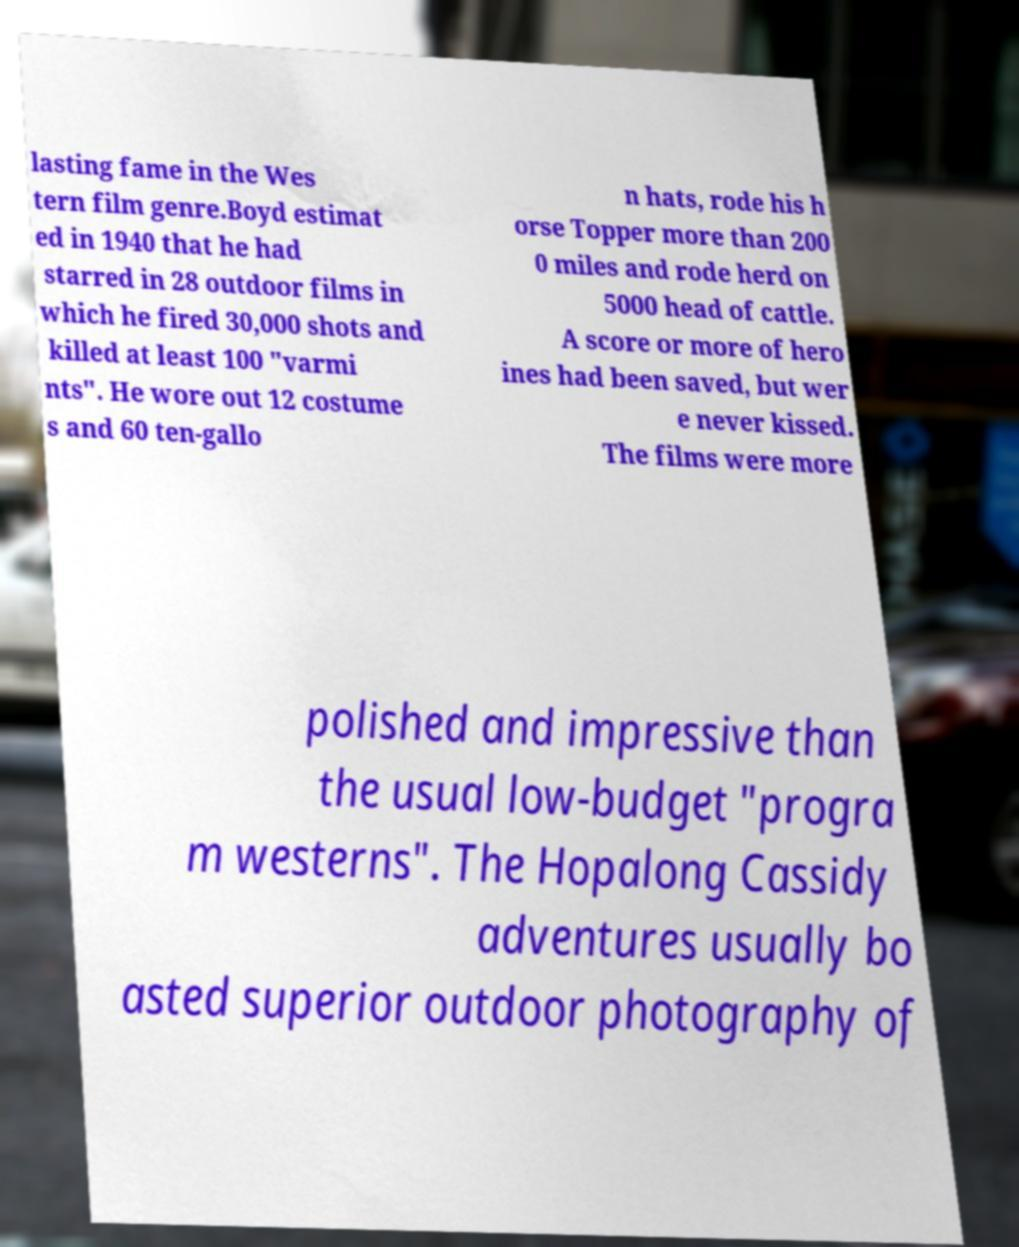Could you assist in decoding the text presented in this image and type it out clearly? lasting fame in the Wes tern film genre.Boyd estimat ed in 1940 that he had starred in 28 outdoor films in which he fired 30,000 shots and killed at least 100 "varmi nts". He wore out 12 costume s and 60 ten-gallo n hats, rode his h orse Topper more than 200 0 miles and rode herd on 5000 head of cattle. A score or more of hero ines had been saved, but wer e never kissed. The films were more polished and impressive than the usual low-budget "progra m westerns". The Hopalong Cassidy adventures usually bo asted superior outdoor photography of 